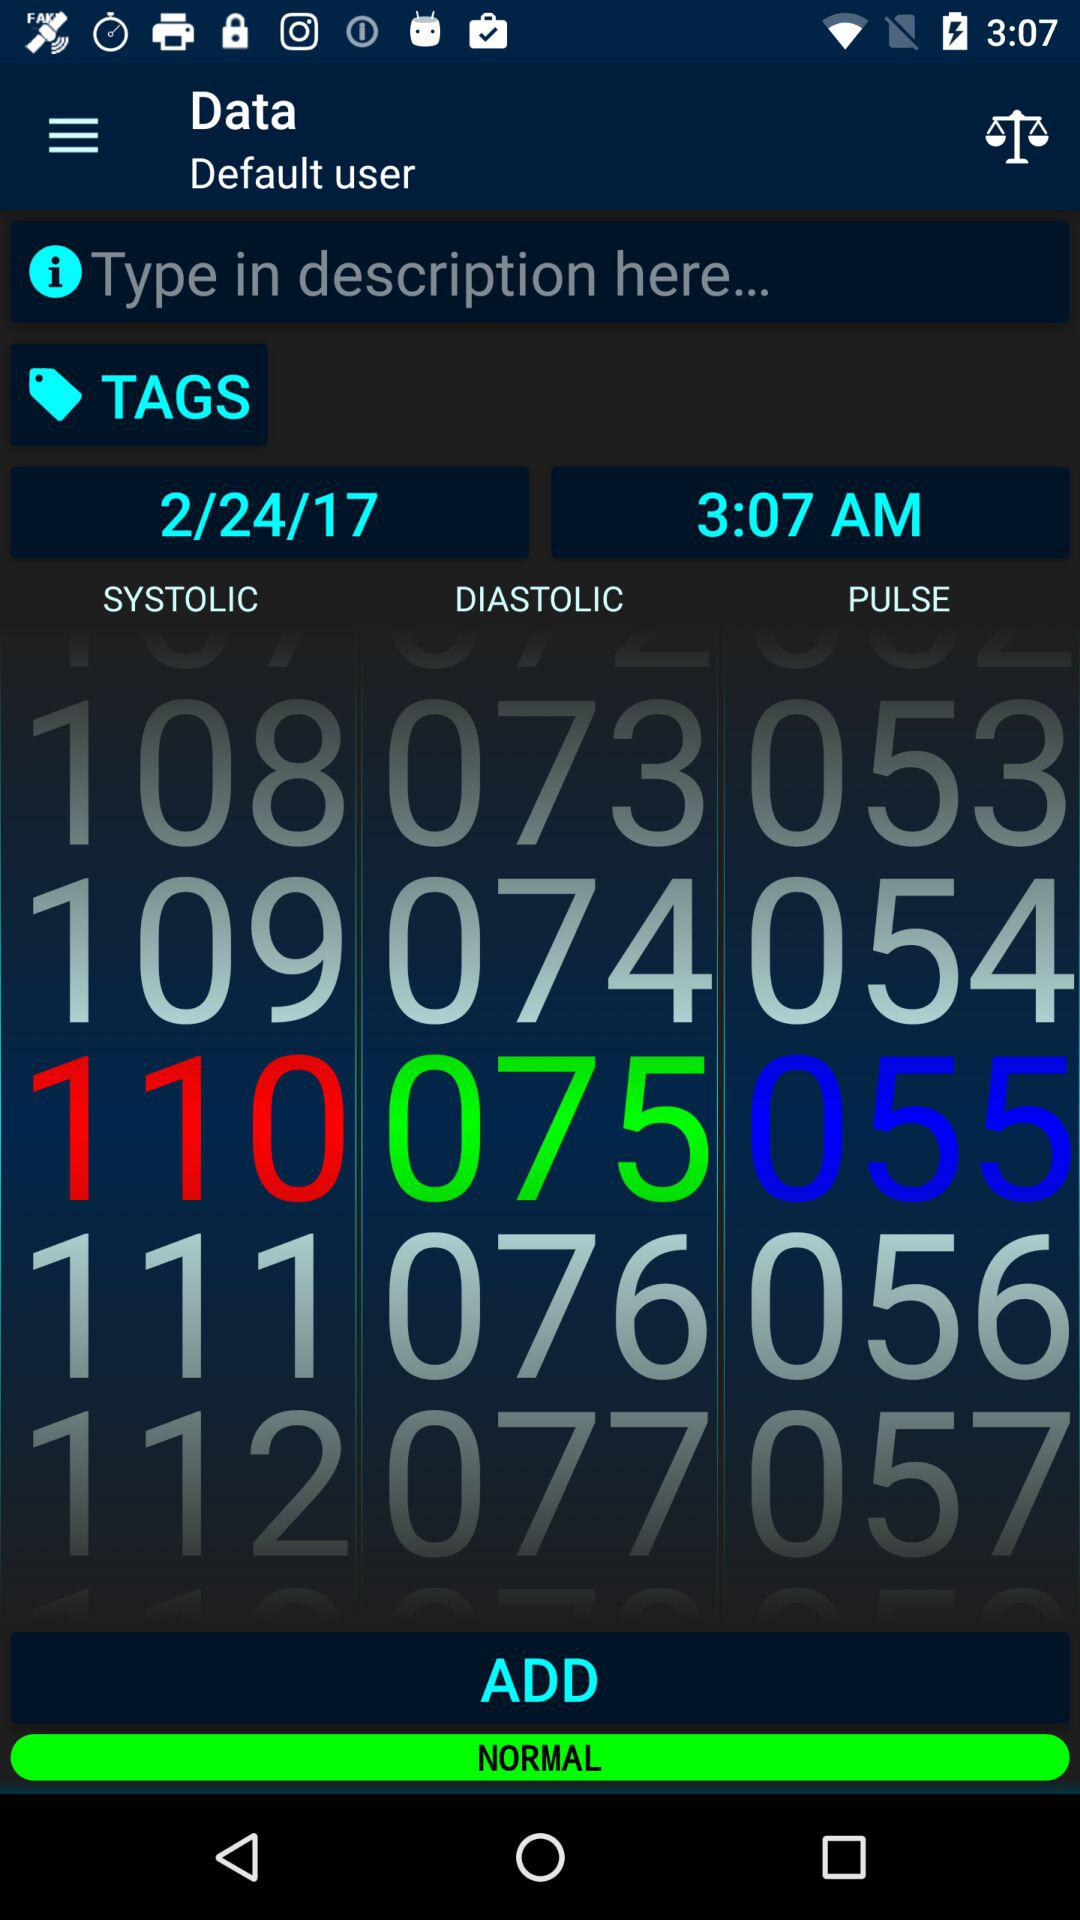What is the selected time? The selected time is 3:07 AM. 